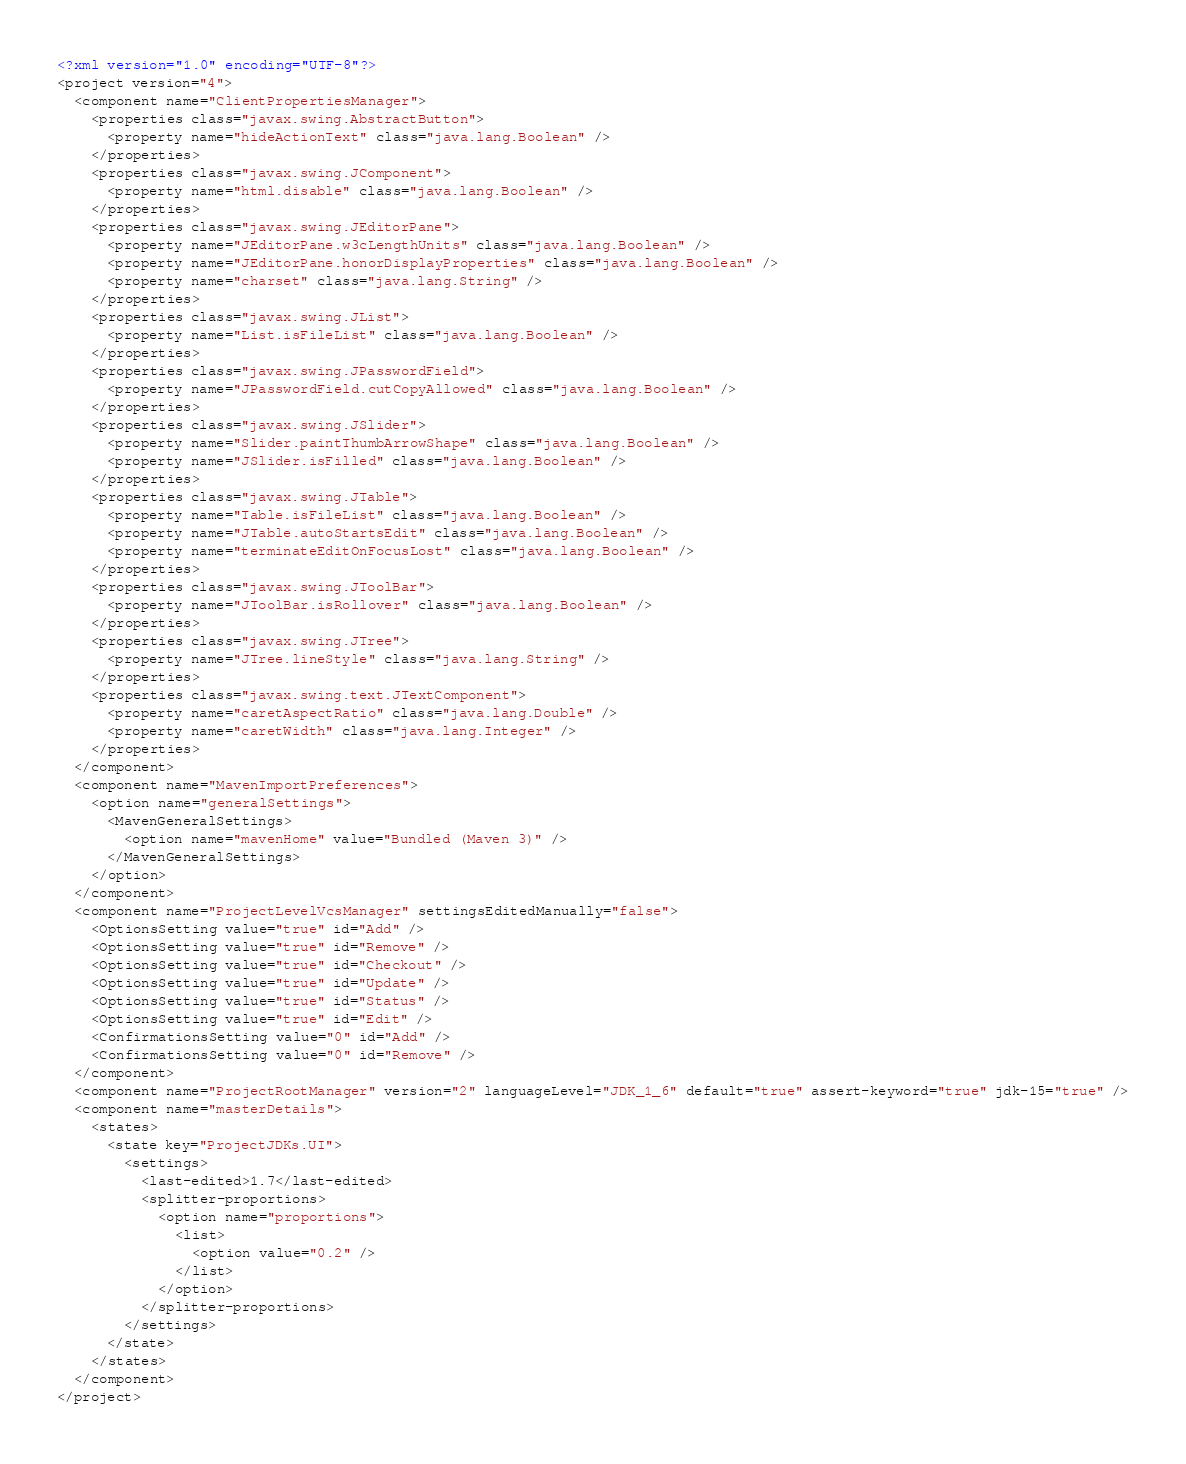<code> <loc_0><loc_0><loc_500><loc_500><_XML_><?xml version="1.0" encoding="UTF-8"?>
<project version="4">
  <component name="ClientPropertiesManager">
    <properties class="javax.swing.AbstractButton">
      <property name="hideActionText" class="java.lang.Boolean" />
    </properties>
    <properties class="javax.swing.JComponent">
      <property name="html.disable" class="java.lang.Boolean" />
    </properties>
    <properties class="javax.swing.JEditorPane">
      <property name="JEditorPane.w3cLengthUnits" class="java.lang.Boolean" />
      <property name="JEditorPane.honorDisplayProperties" class="java.lang.Boolean" />
      <property name="charset" class="java.lang.String" />
    </properties>
    <properties class="javax.swing.JList">
      <property name="List.isFileList" class="java.lang.Boolean" />
    </properties>
    <properties class="javax.swing.JPasswordField">
      <property name="JPasswordField.cutCopyAllowed" class="java.lang.Boolean" />
    </properties>
    <properties class="javax.swing.JSlider">
      <property name="Slider.paintThumbArrowShape" class="java.lang.Boolean" />
      <property name="JSlider.isFilled" class="java.lang.Boolean" />
    </properties>
    <properties class="javax.swing.JTable">
      <property name="Table.isFileList" class="java.lang.Boolean" />
      <property name="JTable.autoStartsEdit" class="java.lang.Boolean" />
      <property name="terminateEditOnFocusLost" class="java.lang.Boolean" />
    </properties>
    <properties class="javax.swing.JToolBar">
      <property name="JToolBar.isRollover" class="java.lang.Boolean" />
    </properties>
    <properties class="javax.swing.JTree">
      <property name="JTree.lineStyle" class="java.lang.String" />
    </properties>
    <properties class="javax.swing.text.JTextComponent">
      <property name="caretAspectRatio" class="java.lang.Double" />
      <property name="caretWidth" class="java.lang.Integer" />
    </properties>
  </component>
  <component name="MavenImportPreferences">
    <option name="generalSettings">
      <MavenGeneralSettings>
        <option name="mavenHome" value="Bundled (Maven 3)" />
      </MavenGeneralSettings>
    </option>
  </component>
  <component name="ProjectLevelVcsManager" settingsEditedManually="false">
    <OptionsSetting value="true" id="Add" />
    <OptionsSetting value="true" id="Remove" />
    <OptionsSetting value="true" id="Checkout" />
    <OptionsSetting value="true" id="Update" />
    <OptionsSetting value="true" id="Status" />
    <OptionsSetting value="true" id="Edit" />
    <ConfirmationsSetting value="0" id="Add" />
    <ConfirmationsSetting value="0" id="Remove" />
  </component>
  <component name="ProjectRootManager" version="2" languageLevel="JDK_1_6" default="true" assert-keyword="true" jdk-15="true" />
  <component name="masterDetails">
    <states>
      <state key="ProjectJDKs.UI">
        <settings>
          <last-edited>1.7</last-edited>
          <splitter-proportions>
            <option name="proportions">
              <list>
                <option value="0.2" />
              </list>
            </option>
          </splitter-proportions>
        </settings>
      </state>
    </states>
  </component>
</project></code> 